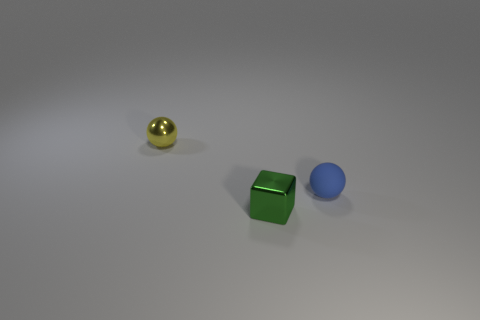How many objects are small metal objects to the left of the small block or objects that are to the right of the small yellow object?
Make the answer very short. 3. Are there an equal number of green metallic cubes that are behind the rubber object and large red balls?
Your response must be concise. Yes. Is there anything else that has the same shape as the small green metal thing?
Keep it short and to the point. No. Do the blue rubber thing and the metallic thing behind the tiny blue rubber object have the same shape?
Your answer should be very brief. Yes. How many other objects are there of the same material as the small block?
Your answer should be very brief. 1. What is the tiny blue thing made of?
Give a very brief answer. Rubber. Are there more tiny shiny things that are on the left side of the small block than large gray cylinders?
Keep it short and to the point. Yes. Do the ball to the left of the matte ball and the tiny matte ball have the same size?
Your response must be concise. Yes. Is there another green metallic block of the same size as the green cube?
Provide a short and direct response. No. What is the color of the metal thing on the right side of the small yellow thing?
Your answer should be compact. Green. 